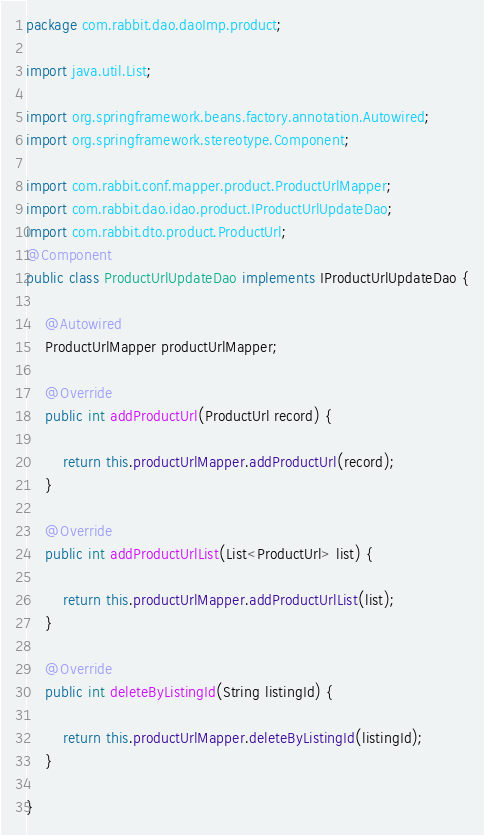<code> <loc_0><loc_0><loc_500><loc_500><_Java_>package com.rabbit.dao.daoImp.product;

import java.util.List;

import org.springframework.beans.factory.annotation.Autowired;
import org.springframework.stereotype.Component;

import com.rabbit.conf.mapper.product.ProductUrlMapper;
import com.rabbit.dao.idao.product.IProductUrlUpdateDao;
import com.rabbit.dto.product.ProductUrl;
@Component
public class ProductUrlUpdateDao implements IProductUrlUpdateDao {

	@Autowired
	ProductUrlMapper productUrlMapper;

	@Override
	public int addProductUrl(ProductUrl record) {

		return this.productUrlMapper.addProductUrl(record);
	}

	@Override
	public int addProductUrlList(List<ProductUrl> list) {

		return this.productUrlMapper.addProductUrlList(list);
	}

	@Override
	public int deleteByListingId(String listingId) {

		return this.productUrlMapper.deleteByListingId(listingId);
	}

}
</code> 